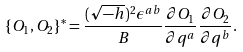<formula> <loc_0><loc_0><loc_500><loc_500>\{ O _ { 1 } , O _ { 2 } \} ^ { * } = \frac { ( \sqrt { - h } ) ^ { 2 } \epsilon ^ { a b } } { B } \frac { \partial O _ { 1 } } { \partial q ^ { a } } \frac { \partial O _ { 2 } } { \partial q ^ { b } } .</formula> 